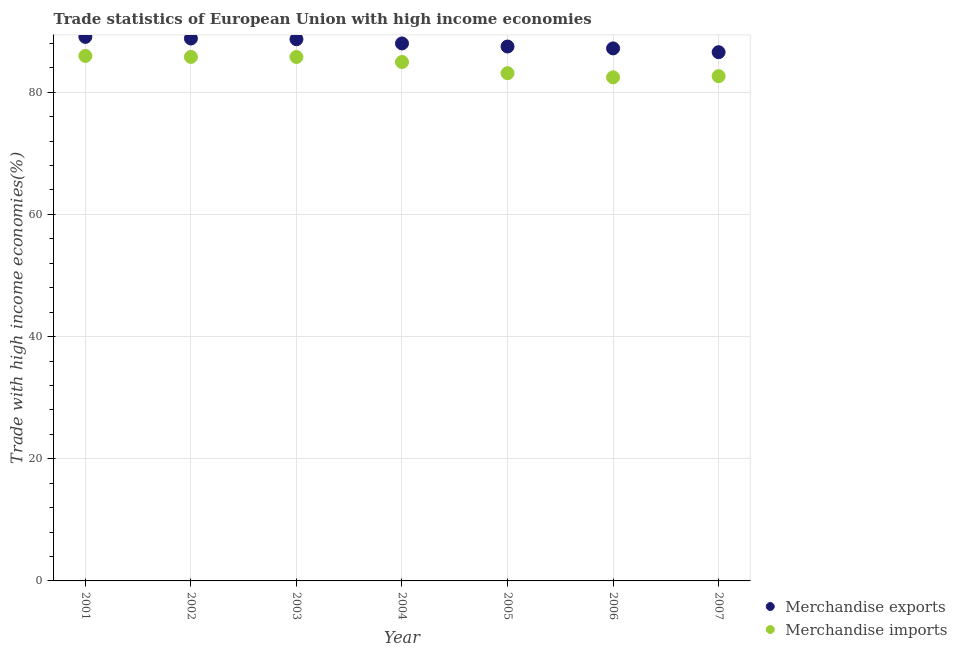What is the merchandise imports in 2004?
Your answer should be compact. 84.95. Across all years, what is the maximum merchandise imports?
Your response must be concise. 85.94. Across all years, what is the minimum merchandise imports?
Keep it short and to the point. 82.44. In which year was the merchandise imports maximum?
Provide a short and direct response. 2001. What is the total merchandise imports in the graph?
Provide a short and direct response. 590.63. What is the difference between the merchandise imports in 2002 and that in 2003?
Give a very brief answer. 0.01. What is the difference between the merchandise imports in 2002 and the merchandise exports in 2005?
Your answer should be very brief. -1.7. What is the average merchandise exports per year?
Your answer should be compact. 87.96. In the year 2007, what is the difference between the merchandise exports and merchandise imports?
Provide a succinct answer. 3.92. What is the ratio of the merchandise exports in 2003 to that in 2004?
Your response must be concise. 1.01. Is the merchandise exports in 2001 less than that in 2002?
Ensure brevity in your answer.  No. Is the difference between the merchandise imports in 2002 and 2003 greater than the difference between the merchandise exports in 2002 and 2003?
Provide a succinct answer. No. What is the difference between the highest and the second highest merchandise imports?
Offer a terse response. 0.16. What is the difference between the highest and the lowest merchandise imports?
Keep it short and to the point. 3.5. In how many years, is the merchandise imports greater than the average merchandise imports taken over all years?
Keep it short and to the point. 4. Is the sum of the merchandise imports in 2003 and 2005 greater than the maximum merchandise exports across all years?
Offer a very short reply. Yes. Does the merchandise exports monotonically increase over the years?
Your answer should be compact. No. Is the merchandise exports strictly greater than the merchandise imports over the years?
Give a very brief answer. Yes. Is the merchandise imports strictly less than the merchandise exports over the years?
Your answer should be very brief. Yes. How many dotlines are there?
Provide a short and direct response. 2. How many years are there in the graph?
Keep it short and to the point. 7. Does the graph contain grids?
Offer a very short reply. Yes. Where does the legend appear in the graph?
Your response must be concise. Bottom right. What is the title of the graph?
Keep it short and to the point. Trade statistics of European Union with high income economies. What is the label or title of the Y-axis?
Provide a short and direct response. Trade with high income economies(%). What is the Trade with high income economies(%) in Merchandise exports in 2001?
Offer a very short reply. 89.06. What is the Trade with high income economies(%) in Merchandise imports in 2001?
Ensure brevity in your answer.  85.94. What is the Trade with high income economies(%) in Merchandise exports in 2002?
Give a very brief answer. 88.8. What is the Trade with high income economies(%) of Merchandise imports in 2002?
Give a very brief answer. 85.78. What is the Trade with high income economies(%) in Merchandise exports in 2003?
Your answer should be very brief. 88.68. What is the Trade with high income economies(%) of Merchandise imports in 2003?
Offer a very short reply. 85.77. What is the Trade with high income economies(%) in Merchandise exports in 2004?
Your answer should be compact. 87.99. What is the Trade with high income economies(%) in Merchandise imports in 2004?
Offer a very short reply. 84.95. What is the Trade with high income economies(%) in Merchandise exports in 2005?
Offer a very short reply. 87.49. What is the Trade with high income economies(%) of Merchandise imports in 2005?
Your answer should be very brief. 83.12. What is the Trade with high income economies(%) in Merchandise exports in 2006?
Ensure brevity in your answer.  87.18. What is the Trade with high income economies(%) in Merchandise imports in 2006?
Keep it short and to the point. 82.44. What is the Trade with high income economies(%) in Merchandise exports in 2007?
Your answer should be very brief. 86.56. What is the Trade with high income economies(%) of Merchandise imports in 2007?
Your answer should be compact. 82.63. Across all years, what is the maximum Trade with high income economies(%) of Merchandise exports?
Provide a succinct answer. 89.06. Across all years, what is the maximum Trade with high income economies(%) of Merchandise imports?
Your answer should be compact. 85.94. Across all years, what is the minimum Trade with high income economies(%) of Merchandise exports?
Provide a short and direct response. 86.56. Across all years, what is the minimum Trade with high income economies(%) of Merchandise imports?
Provide a succinct answer. 82.44. What is the total Trade with high income economies(%) of Merchandise exports in the graph?
Your answer should be very brief. 615.74. What is the total Trade with high income economies(%) of Merchandise imports in the graph?
Make the answer very short. 590.63. What is the difference between the Trade with high income economies(%) in Merchandise exports in 2001 and that in 2002?
Offer a very short reply. 0.26. What is the difference between the Trade with high income economies(%) in Merchandise imports in 2001 and that in 2002?
Your response must be concise. 0.16. What is the difference between the Trade with high income economies(%) in Merchandise exports in 2001 and that in 2003?
Your answer should be very brief. 0.38. What is the difference between the Trade with high income economies(%) of Merchandise imports in 2001 and that in 2003?
Offer a terse response. 0.17. What is the difference between the Trade with high income economies(%) of Merchandise exports in 2001 and that in 2004?
Provide a short and direct response. 1.07. What is the difference between the Trade with high income economies(%) in Merchandise exports in 2001 and that in 2005?
Keep it short and to the point. 1.57. What is the difference between the Trade with high income economies(%) in Merchandise imports in 2001 and that in 2005?
Provide a short and direct response. 2.83. What is the difference between the Trade with high income economies(%) of Merchandise exports in 2001 and that in 2006?
Provide a short and direct response. 1.88. What is the difference between the Trade with high income economies(%) in Merchandise imports in 2001 and that in 2006?
Your answer should be very brief. 3.5. What is the difference between the Trade with high income economies(%) of Merchandise exports in 2001 and that in 2007?
Give a very brief answer. 2.5. What is the difference between the Trade with high income economies(%) in Merchandise imports in 2001 and that in 2007?
Offer a terse response. 3.31. What is the difference between the Trade with high income economies(%) in Merchandise exports in 2002 and that in 2003?
Provide a succinct answer. 0.12. What is the difference between the Trade with high income economies(%) of Merchandise imports in 2002 and that in 2003?
Your answer should be very brief. 0.01. What is the difference between the Trade with high income economies(%) of Merchandise exports in 2002 and that in 2004?
Your answer should be very brief. 0.81. What is the difference between the Trade with high income economies(%) of Merchandise imports in 2002 and that in 2004?
Provide a short and direct response. 0.83. What is the difference between the Trade with high income economies(%) of Merchandise exports in 2002 and that in 2005?
Your answer should be very brief. 1.31. What is the difference between the Trade with high income economies(%) in Merchandise imports in 2002 and that in 2005?
Offer a very short reply. 2.66. What is the difference between the Trade with high income economies(%) in Merchandise exports in 2002 and that in 2006?
Offer a very short reply. 1.62. What is the difference between the Trade with high income economies(%) of Merchandise imports in 2002 and that in 2006?
Offer a terse response. 3.34. What is the difference between the Trade with high income economies(%) of Merchandise exports in 2002 and that in 2007?
Provide a succinct answer. 2.24. What is the difference between the Trade with high income economies(%) of Merchandise imports in 2002 and that in 2007?
Your answer should be very brief. 3.15. What is the difference between the Trade with high income economies(%) of Merchandise exports in 2003 and that in 2004?
Make the answer very short. 0.69. What is the difference between the Trade with high income economies(%) of Merchandise imports in 2003 and that in 2004?
Provide a short and direct response. 0.82. What is the difference between the Trade with high income economies(%) in Merchandise exports in 2003 and that in 2005?
Your answer should be very brief. 1.19. What is the difference between the Trade with high income economies(%) in Merchandise imports in 2003 and that in 2005?
Ensure brevity in your answer.  2.66. What is the difference between the Trade with high income economies(%) in Merchandise exports in 2003 and that in 2006?
Offer a terse response. 1.5. What is the difference between the Trade with high income economies(%) of Merchandise imports in 2003 and that in 2006?
Offer a terse response. 3.33. What is the difference between the Trade with high income economies(%) of Merchandise exports in 2003 and that in 2007?
Ensure brevity in your answer.  2.12. What is the difference between the Trade with high income economies(%) in Merchandise imports in 2003 and that in 2007?
Your answer should be compact. 3.14. What is the difference between the Trade with high income economies(%) in Merchandise exports in 2004 and that in 2005?
Your answer should be very brief. 0.5. What is the difference between the Trade with high income economies(%) of Merchandise imports in 2004 and that in 2005?
Your response must be concise. 1.83. What is the difference between the Trade with high income economies(%) in Merchandise exports in 2004 and that in 2006?
Provide a succinct answer. 0.81. What is the difference between the Trade with high income economies(%) of Merchandise imports in 2004 and that in 2006?
Provide a succinct answer. 2.51. What is the difference between the Trade with high income economies(%) in Merchandise exports in 2004 and that in 2007?
Provide a succinct answer. 1.43. What is the difference between the Trade with high income economies(%) of Merchandise imports in 2004 and that in 2007?
Offer a terse response. 2.32. What is the difference between the Trade with high income economies(%) of Merchandise exports in 2005 and that in 2006?
Provide a succinct answer. 0.31. What is the difference between the Trade with high income economies(%) in Merchandise imports in 2005 and that in 2006?
Your response must be concise. 0.68. What is the difference between the Trade with high income economies(%) in Merchandise exports in 2005 and that in 2007?
Provide a short and direct response. 0.93. What is the difference between the Trade with high income economies(%) in Merchandise imports in 2005 and that in 2007?
Keep it short and to the point. 0.48. What is the difference between the Trade with high income economies(%) in Merchandise exports in 2006 and that in 2007?
Provide a succinct answer. 0.62. What is the difference between the Trade with high income economies(%) of Merchandise imports in 2006 and that in 2007?
Give a very brief answer. -0.19. What is the difference between the Trade with high income economies(%) in Merchandise exports in 2001 and the Trade with high income economies(%) in Merchandise imports in 2002?
Your answer should be compact. 3.28. What is the difference between the Trade with high income economies(%) in Merchandise exports in 2001 and the Trade with high income economies(%) in Merchandise imports in 2003?
Offer a very short reply. 3.29. What is the difference between the Trade with high income economies(%) in Merchandise exports in 2001 and the Trade with high income economies(%) in Merchandise imports in 2004?
Your answer should be very brief. 4.11. What is the difference between the Trade with high income economies(%) of Merchandise exports in 2001 and the Trade with high income economies(%) of Merchandise imports in 2005?
Give a very brief answer. 5.94. What is the difference between the Trade with high income economies(%) in Merchandise exports in 2001 and the Trade with high income economies(%) in Merchandise imports in 2006?
Your answer should be compact. 6.62. What is the difference between the Trade with high income economies(%) of Merchandise exports in 2001 and the Trade with high income economies(%) of Merchandise imports in 2007?
Ensure brevity in your answer.  6.43. What is the difference between the Trade with high income economies(%) in Merchandise exports in 2002 and the Trade with high income economies(%) in Merchandise imports in 2003?
Your answer should be very brief. 3.02. What is the difference between the Trade with high income economies(%) in Merchandise exports in 2002 and the Trade with high income economies(%) in Merchandise imports in 2004?
Provide a short and direct response. 3.85. What is the difference between the Trade with high income economies(%) in Merchandise exports in 2002 and the Trade with high income economies(%) in Merchandise imports in 2005?
Ensure brevity in your answer.  5.68. What is the difference between the Trade with high income economies(%) in Merchandise exports in 2002 and the Trade with high income economies(%) in Merchandise imports in 2006?
Provide a short and direct response. 6.36. What is the difference between the Trade with high income economies(%) of Merchandise exports in 2002 and the Trade with high income economies(%) of Merchandise imports in 2007?
Give a very brief answer. 6.16. What is the difference between the Trade with high income economies(%) of Merchandise exports in 2003 and the Trade with high income economies(%) of Merchandise imports in 2004?
Offer a terse response. 3.73. What is the difference between the Trade with high income economies(%) of Merchandise exports in 2003 and the Trade with high income economies(%) of Merchandise imports in 2005?
Your answer should be very brief. 5.56. What is the difference between the Trade with high income economies(%) in Merchandise exports in 2003 and the Trade with high income economies(%) in Merchandise imports in 2006?
Keep it short and to the point. 6.24. What is the difference between the Trade with high income economies(%) in Merchandise exports in 2003 and the Trade with high income economies(%) in Merchandise imports in 2007?
Your response must be concise. 6.04. What is the difference between the Trade with high income economies(%) of Merchandise exports in 2004 and the Trade with high income economies(%) of Merchandise imports in 2005?
Your answer should be compact. 4.87. What is the difference between the Trade with high income economies(%) of Merchandise exports in 2004 and the Trade with high income economies(%) of Merchandise imports in 2006?
Give a very brief answer. 5.55. What is the difference between the Trade with high income economies(%) in Merchandise exports in 2004 and the Trade with high income economies(%) in Merchandise imports in 2007?
Make the answer very short. 5.35. What is the difference between the Trade with high income economies(%) in Merchandise exports in 2005 and the Trade with high income economies(%) in Merchandise imports in 2006?
Offer a terse response. 5.05. What is the difference between the Trade with high income economies(%) of Merchandise exports in 2005 and the Trade with high income economies(%) of Merchandise imports in 2007?
Your answer should be compact. 4.85. What is the difference between the Trade with high income economies(%) in Merchandise exports in 2006 and the Trade with high income economies(%) in Merchandise imports in 2007?
Provide a short and direct response. 4.54. What is the average Trade with high income economies(%) of Merchandise exports per year?
Make the answer very short. 87.96. What is the average Trade with high income economies(%) of Merchandise imports per year?
Your answer should be very brief. 84.38. In the year 2001, what is the difference between the Trade with high income economies(%) of Merchandise exports and Trade with high income economies(%) of Merchandise imports?
Provide a succinct answer. 3.12. In the year 2002, what is the difference between the Trade with high income economies(%) in Merchandise exports and Trade with high income economies(%) in Merchandise imports?
Your answer should be compact. 3.02. In the year 2003, what is the difference between the Trade with high income economies(%) in Merchandise exports and Trade with high income economies(%) in Merchandise imports?
Your answer should be very brief. 2.9. In the year 2004, what is the difference between the Trade with high income economies(%) of Merchandise exports and Trade with high income economies(%) of Merchandise imports?
Your answer should be compact. 3.04. In the year 2005, what is the difference between the Trade with high income economies(%) of Merchandise exports and Trade with high income economies(%) of Merchandise imports?
Keep it short and to the point. 4.37. In the year 2006, what is the difference between the Trade with high income economies(%) of Merchandise exports and Trade with high income economies(%) of Merchandise imports?
Offer a very short reply. 4.74. In the year 2007, what is the difference between the Trade with high income economies(%) in Merchandise exports and Trade with high income economies(%) in Merchandise imports?
Keep it short and to the point. 3.92. What is the ratio of the Trade with high income economies(%) in Merchandise exports in 2001 to that in 2002?
Keep it short and to the point. 1. What is the ratio of the Trade with high income economies(%) in Merchandise imports in 2001 to that in 2002?
Provide a short and direct response. 1. What is the ratio of the Trade with high income economies(%) in Merchandise exports in 2001 to that in 2003?
Give a very brief answer. 1. What is the ratio of the Trade with high income economies(%) in Merchandise imports in 2001 to that in 2003?
Offer a terse response. 1. What is the ratio of the Trade with high income economies(%) of Merchandise exports in 2001 to that in 2004?
Your answer should be very brief. 1.01. What is the ratio of the Trade with high income economies(%) in Merchandise imports in 2001 to that in 2004?
Keep it short and to the point. 1.01. What is the ratio of the Trade with high income economies(%) of Merchandise exports in 2001 to that in 2005?
Offer a terse response. 1.02. What is the ratio of the Trade with high income economies(%) of Merchandise imports in 2001 to that in 2005?
Keep it short and to the point. 1.03. What is the ratio of the Trade with high income economies(%) of Merchandise exports in 2001 to that in 2006?
Give a very brief answer. 1.02. What is the ratio of the Trade with high income economies(%) of Merchandise imports in 2001 to that in 2006?
Make the answer very short. 1.04. What is the ratio of the Trade with high income economies(%) in Merchandise exports in 2001 to that in 2007?
Your answer should be very brief. 1.03. What is the ratio of the Trade with high income economies(%) in Merchandise exports in 2002 to that in 2004?
Keep it short and to the point. 1.01. What is the ratio of the Trade with high income economies(%) in Merchandise imports in 2002 to that in 2004?
Provide a short and direct response. 1.01. What is the ratio of the Trade with high income economies(%) in Merchandise imports in 2002 to that in 2005?
Provide a succinct answer. 1.03. What is the ratio of the Trade with high income economies(%) of Merchandise exports in 2002 to that in 2006?
Provide a succinct answer. 1.02. What is the ratio of the Trade with high income economies(%) of Merchandise imports in 2002 to that in 2006?
Offer a very short reply. 1.04. What is the ratio of the Trade with high income economies(%) in Merchandise exports in 2002 to that in 2007?
Keep it short and to the point. 1.03. What is the ratio of the Trade with high income economies(%) in Merchandise imports in 2002 to that in 2007?
Make the answer very short. 1.04. What is the ratio of the Trade with high income economies(%) in Merchandise exports in 2003 to that in 2004?
Give a very brief answer. 1.01. What is the ratio of the Trade with high income economies(%) of Merchandise imports in 2003 to that in 2004?
Make the answer very short. 1.01. What is the ratio of the Trade with high income economies(%) of Merchandise exports in 2003 to that in 2005?
Your response must be concise. 1.01. What is the ratio of the Trade with high income economies(%) of Merchandise imports in 2003 to that in 2005?
Provide a succinct answer. 1.03. What is the ratio of the Trade with high income economies(%) of Merchandise exports in 2003 to that in 2006?
Ensure brevity in your answer.  1.02. What is the ratio of the Trade with high income economies(%) in Merchandise imports in 2003 to that in 2006?
Keep it short and to the point. 1.04. What is the ratio of the Trade with high income economies(%) in Merchandise exports in 2003 to that in 2007?
Your answer should be very brief. 1.02. What is the ratio of the Trade with high income economies(%) of Merchandise imports in 2003 to that in 2007?
Provide a short and direct response. 1.04. What is the ratio of the Trade with high income economies(%) in Merchandise exports in 2004 to that in 2005?
Your response must be concise. 1.01. What is the ratio of the Trade with high income economies(%) of Merchandise imports in 2004 to that in 2005?
Provide a succinct answer. 1.02. What is the ratio of the Trade with high income economies(%) of Merchandise exports in 2004 to that in 2006?
Offer a terse response. 1.01. What is the ratio of the Trade with high income economies(%) in Merchandise imports in 2004 to that in 2006?
Keep it short and to the point. 1.03. What is the ratio of the Trade with high income economies(%) in Merchandise exports in 2004 to that in 2007?
Ensure brevity in your answer.  1.02. What is the ratio of the Trade with high income economies(%) in Merchandise imports in 2004 to that in 2007?
Provide a short and direct response. 1.03. What is the ratio of the Trade with high income economies(%) in Merchandise exports in 2005 to that in 2006?
Offer a terse response. 1. What is the ratio of the Trade with high income economies(%) in Merchandise imports in 2005 to that in 2006?
Give a very brief answer. 1.01. What is the ratio of the Trade with high income economies(%) of Merchandise exports in 2005 to that in 2007?
Make the answer very short. 1.01. What is the ratio of the Trade with high income economies(%) of Merchandise imports in 2005 to that in 2007?
Give a very brief answer. 1.01. What is the ratio of the Trade with high income economies(%) of Merchandise exports in 2006 to that in 2007?
Give a very brief answer. 1.01. What is the ratio of the Trade with high income economies(%) in Merchandise imports in 2006 to that in 2007?
Your response must be concise. 1. What is the difference between the highest and the second highest Trade with high income economies(%) in Merchandise exports?
Provide a short and direct response. 0.26. What is the difference between the highest and the second highest Trade with high income economies(%) of Merchandise imports?
Offer a terse response. 0.16. What is the difference between the highest and the lowest Trade with high income economies(%) in Merchandise exports?
Provide a succinct answer. 2.5. What is the difference between the highest and the lowest Trade with high income economies(%) in Merchandise imports?
Offer a very short reply. 3.5. 